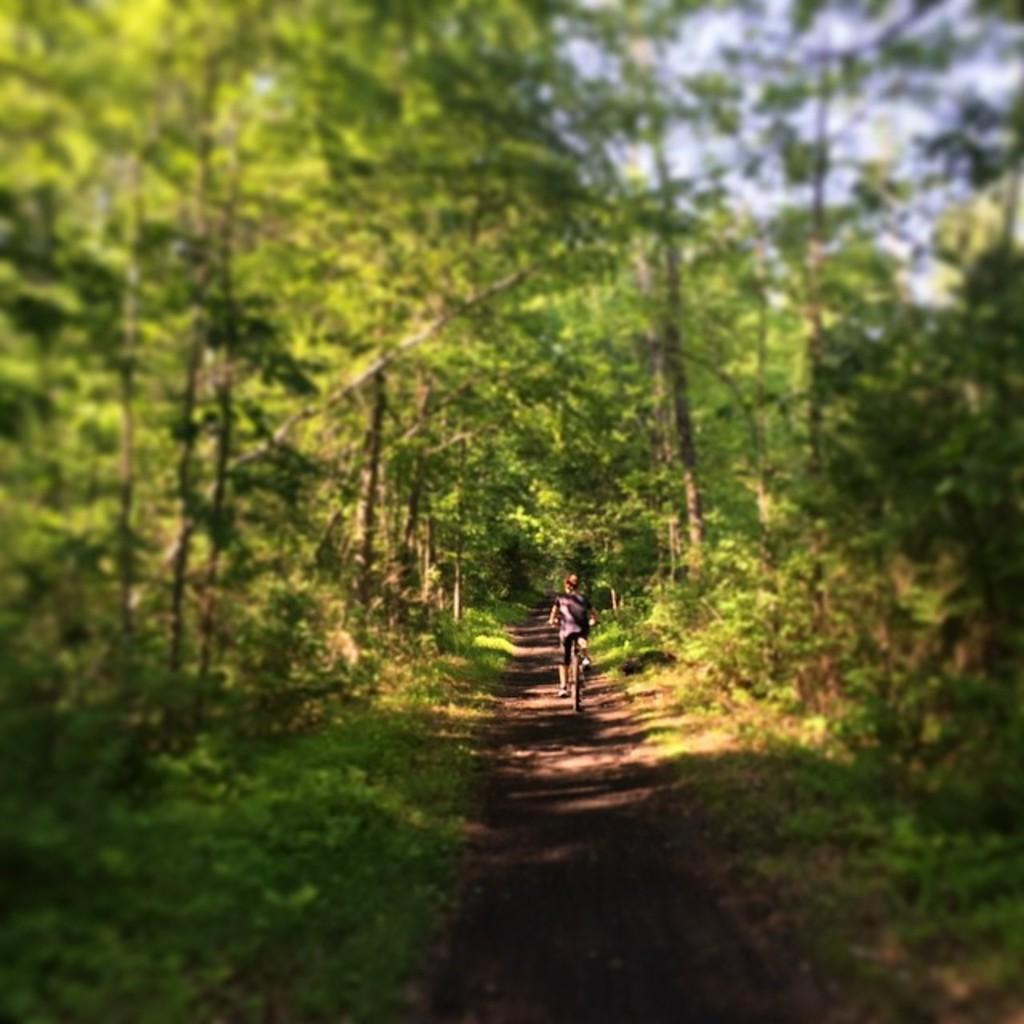What is the main subject of the image? There is a person in the image. What is the person doing in the image? The person is riding a cycle. Where is the cycle located in the image? The cycle is on a path. What can be seen around the path in the image? The path is surrounded by grass, and trees are present near the path. How many wings does the person have in the image? The person does not have any wings in the image. What type of selection is being made in the image? There is no selection process depicted in the image; it shows a person riding a cycle on a path. 